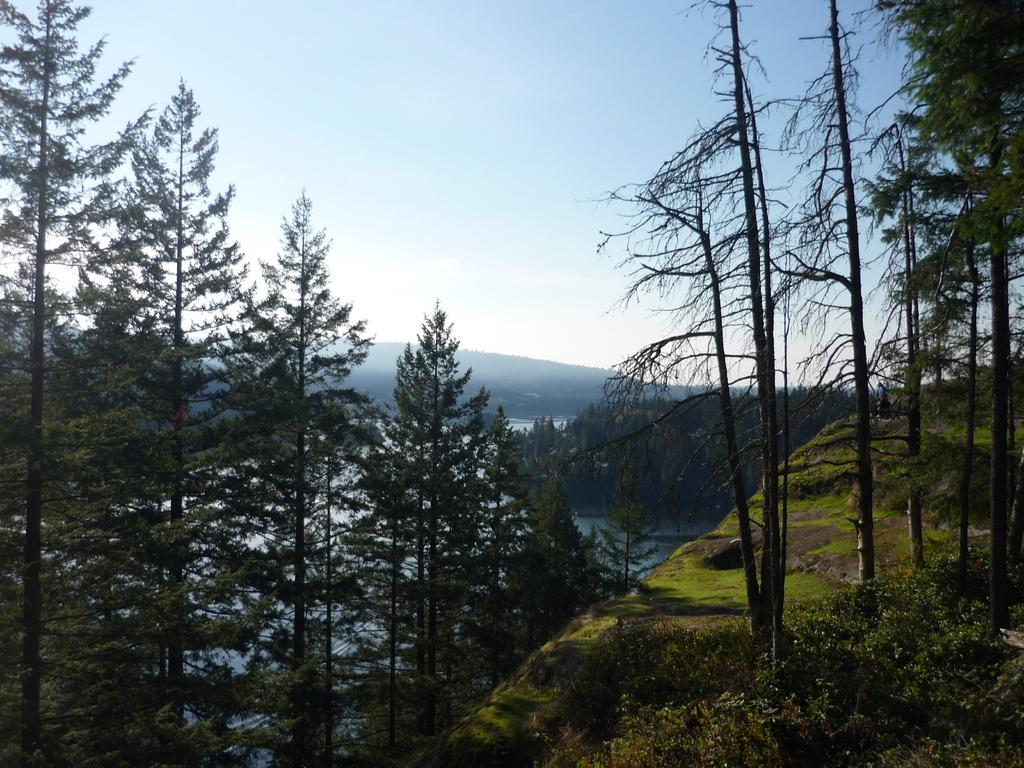What type of vegetation can be seen in the image? There are trees and grass in the image. What natural element is visible in the image? There is water visible in the image. What other living organisms can be seen in the image? There are plants in the image. What else is present in the image besides vegetation and water? There are other objects in the image. What can be seen in the background of the image? The sky is visible in the background of the image. What color is the head of the sweater in the image? There is no sweater or head present in the image. How many cards are visible in the image? There are no cards visible in the image. 